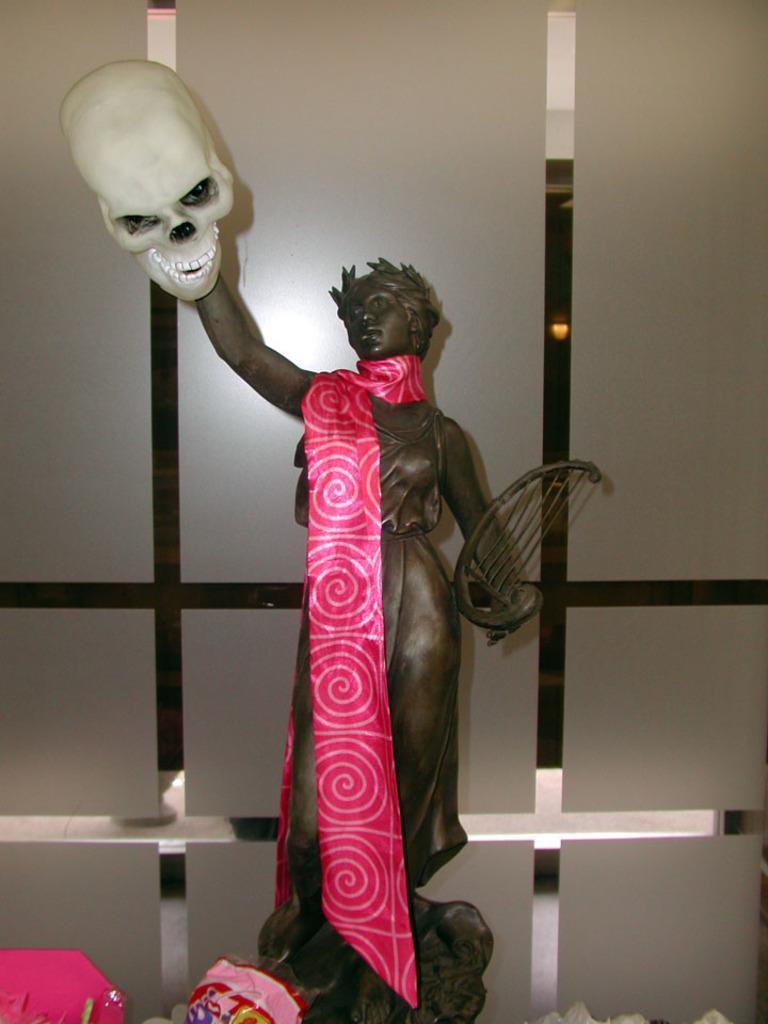Can you describe this image briefly? In this image, we can see a sculpture in front of the glass wall. 